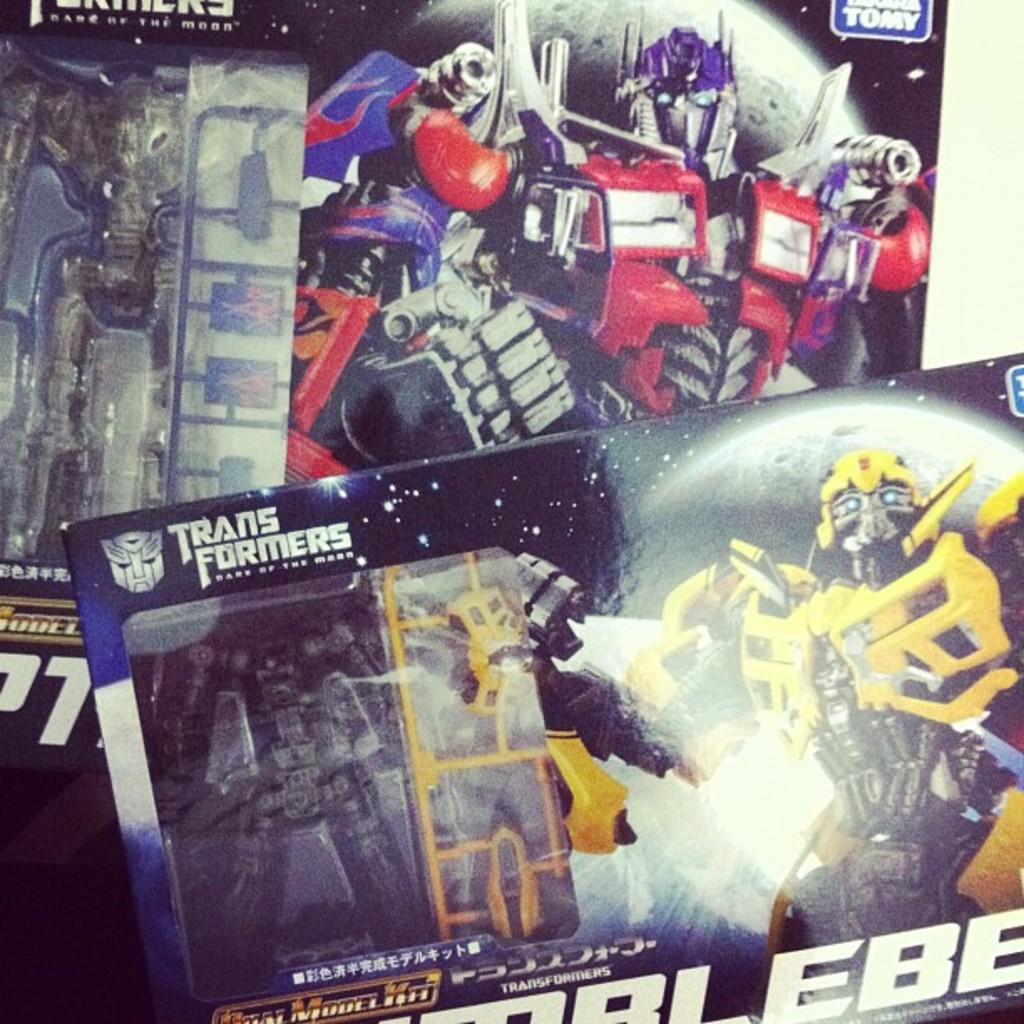What is present on the banners in the image? The banners in the image have text and images on them. Can you describe the text on the banners? Unfortunately, the specific text on the banners cannot be determined from the image alone. What types of images are on the banners? The images on the banners cannot be identified from the image alone, but they are visible on the banners. Can you describe the grass and earth in the image? There is no grass or earth present in the image; the image only features banners with text and images. 